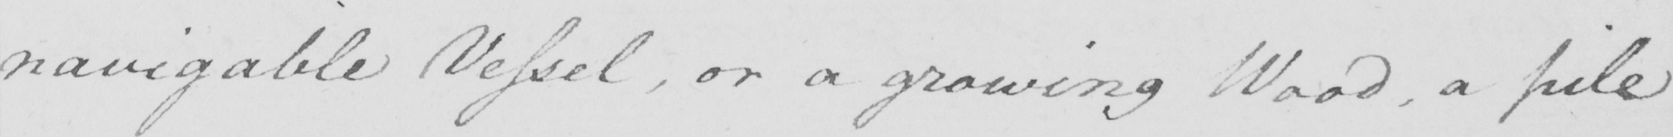Can you read and transcribe this handwriting? navigable Vessel , or a growing Wood , a pile 